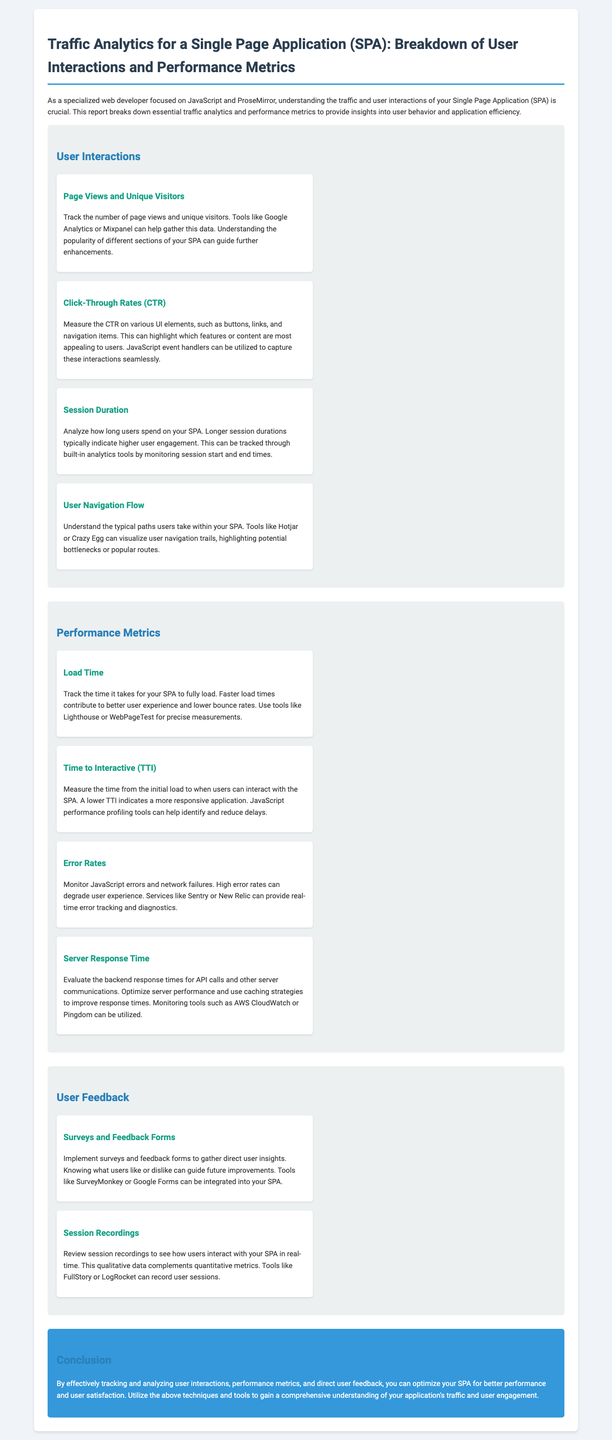What is the main focus of the report? The report focuses on analyzing traffic analytics and performance metrics for a Single Page Application.
Answer: Traffic analytics and performance metrics for a Single Page Application Which tool can help track page views and unique visitors? The document mentions tools like Google Analytics or Mixpanel for gathering this data.
Answer: Google Analytics or Mixpanel What does a lower Time to Interactive (TTI) indicate? The document states that a lower TTI indicates a more responsive application.
Answer: More responsive application What is one method to gather direct user insights? The report suggests implementing surveys and feedback forms to gather these insights.
Answer: Surveys and feedback forms Which tool is mentioned for tracking JavaScript errors and network failures? The report includes services like Sentry or New Relic for real-time error tracking and diagnostics.
Answer: Sentry or New Relic 